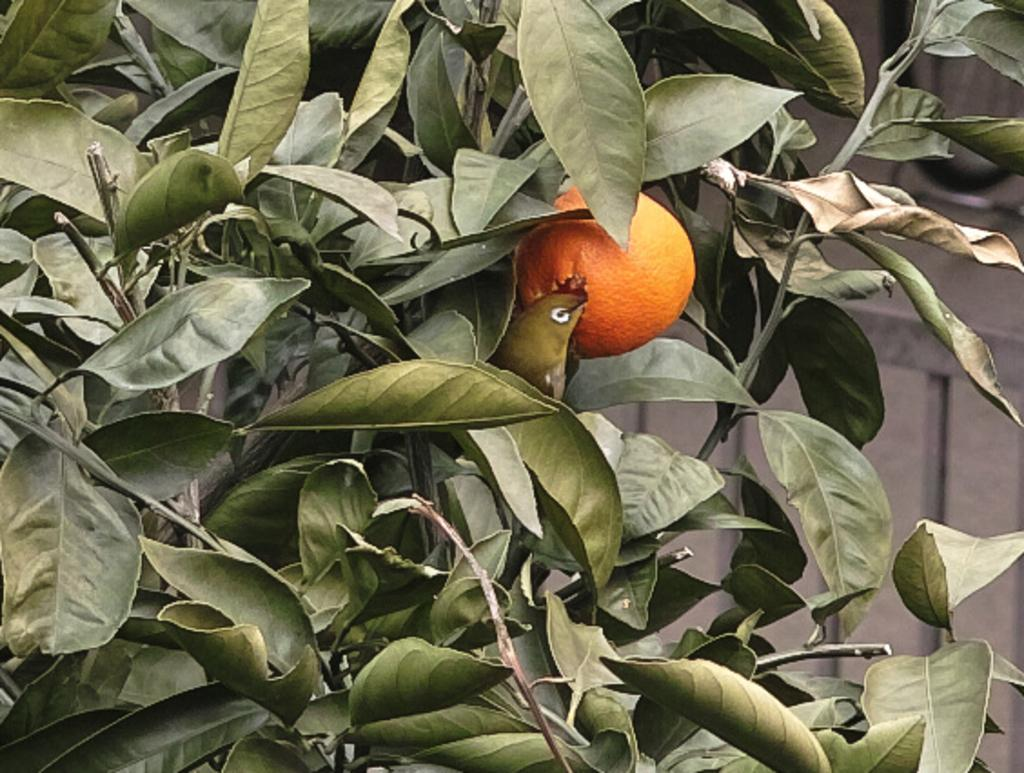What type of plant can be seen in the picture? There is a tree in the picture. What is the tree holding or producing? There is a fruit in the picture. What can be seen in the background of the picture? There is a wall in the background of the picture. What type of jelly is being used to stop the tree from growing in the picture? There is no jelly or indication of stopping the tree's growth in the picture. 